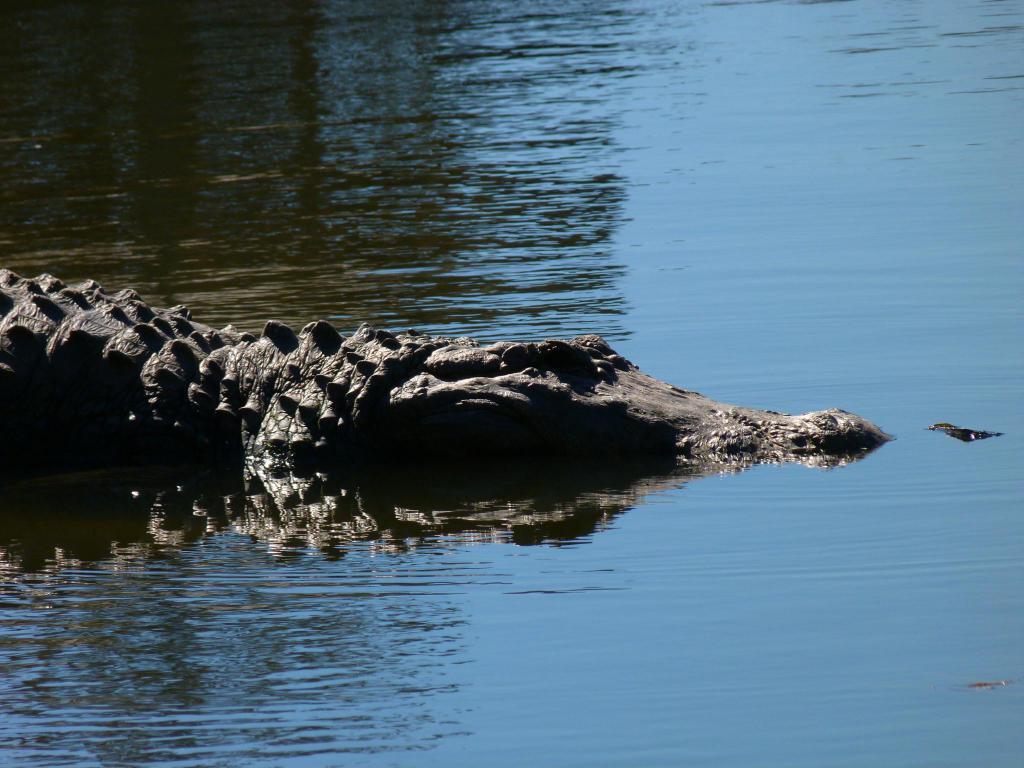Can you describe this image briefly? In this image there is water, there is a crocodile towards the left of the image. 